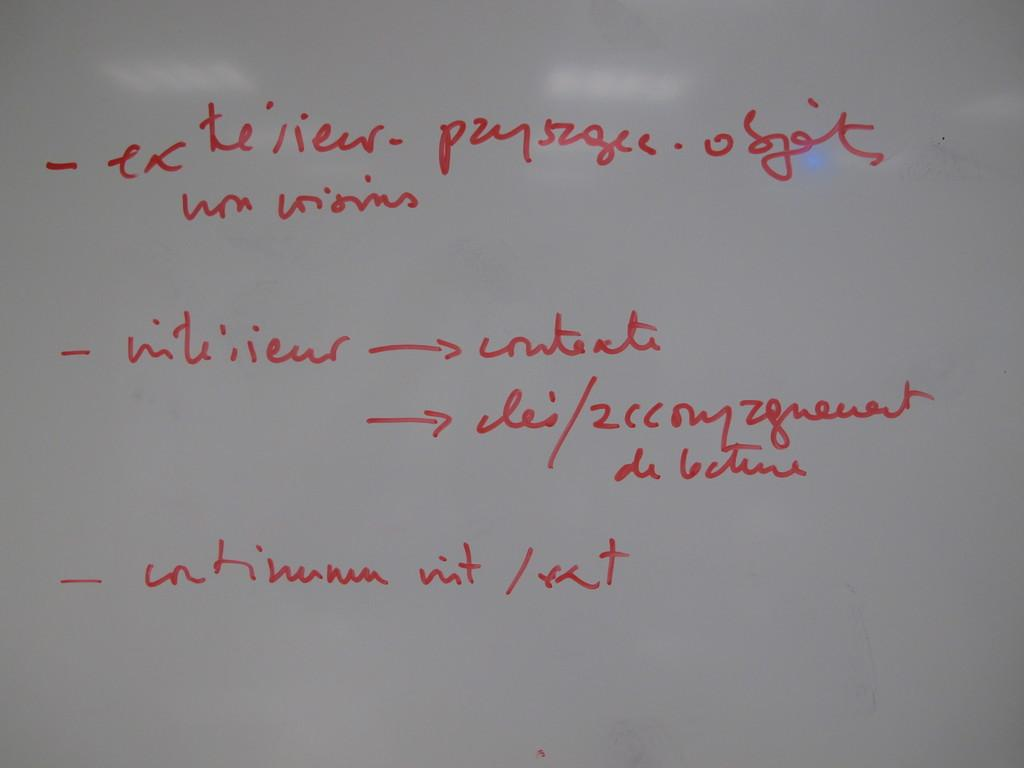What is the main object in the image? There is a whiteboard in the image. What is written on the whiteboard? There is text written on the whiteboard. What color is the text on the whiteboard? The text is in red color. How many trains can be seen swimming in the image? There are no trains or swimming depicted in the image; it features a whiteboard with red text. 